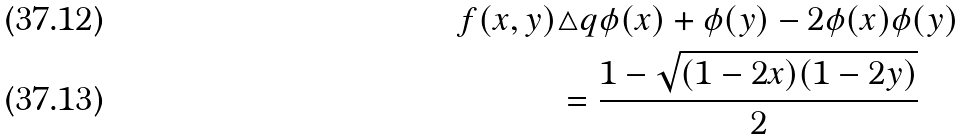Convert formula to latex. <formula><loc_0><loc_0><loc_500><loc_500>f ( x , y ) & \triangle q \phi ( x ) + \phi ( y ) - 2 \phi ( x ) \phi ( y ) \\ & = \frac { 1 - \sqrt { ( 1 - 2 x ) ( 1 - 2 y ) } } { 2 }</formula> 